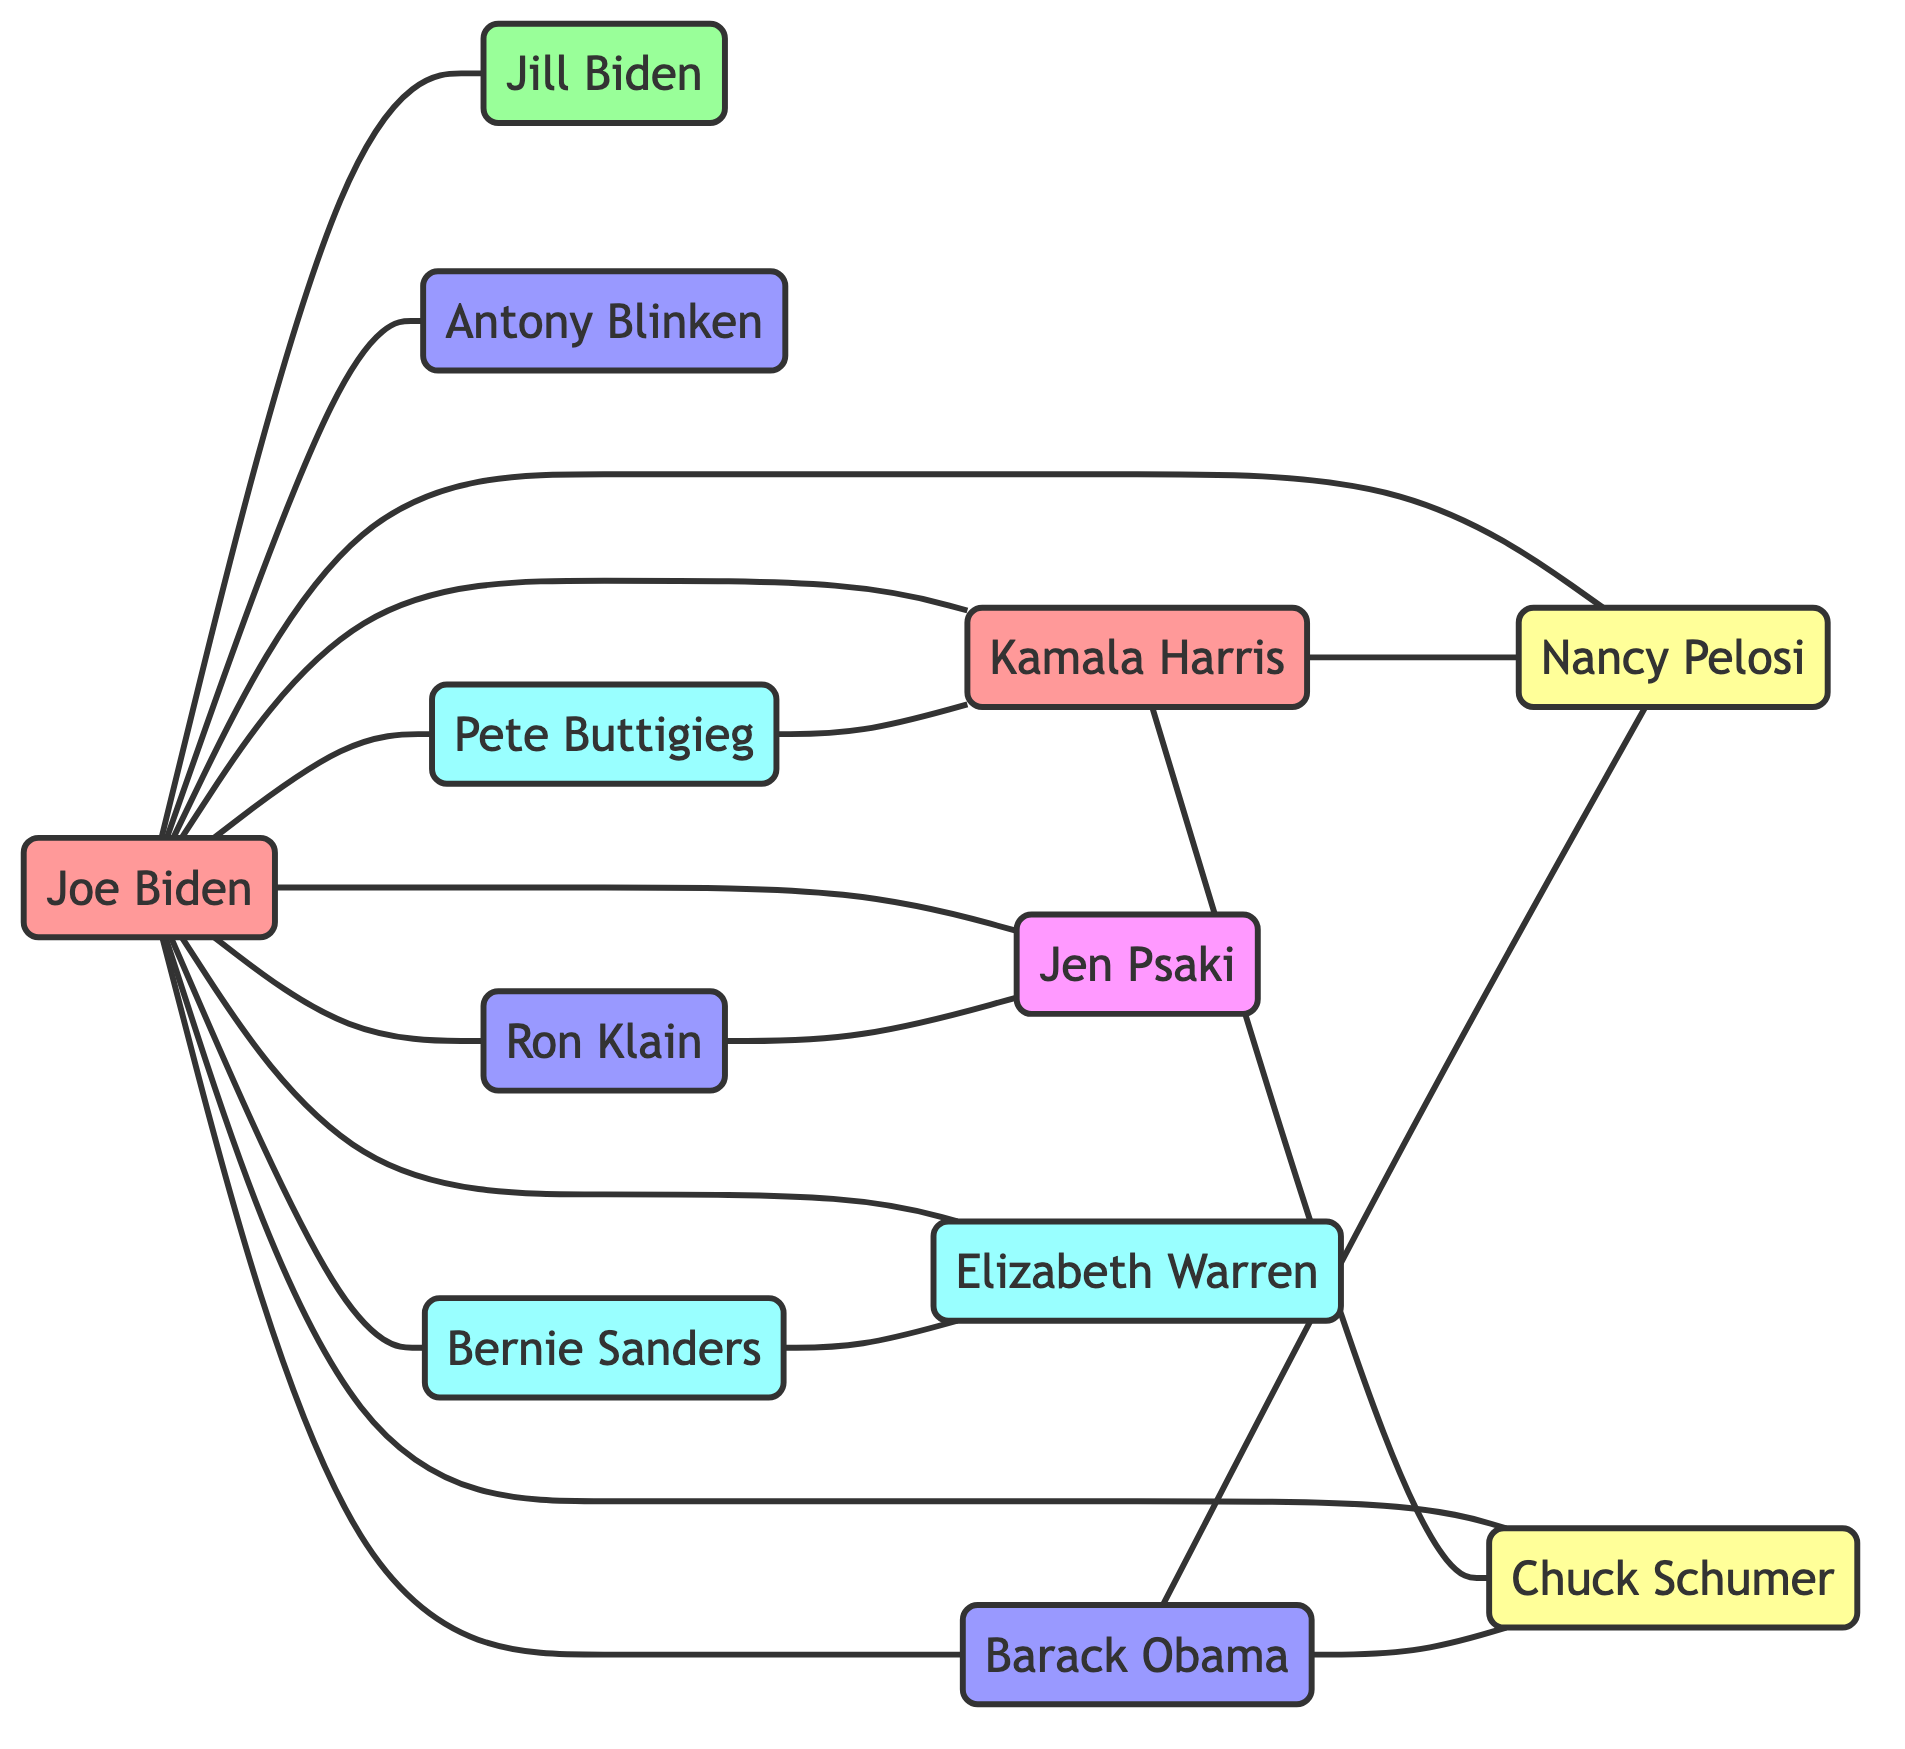What is the total number of nodes in the diagram? To find the total number of nodes, we count each unique person in the "nodes" list. There are 12 distinct nodes listed: Joe Biden, Kamala Harris, Jill Biden, Barack Obama, Nancy Pelosi, Chuck Schumer, Antony Blinken, Ron Klain, Jen Psaki, Elizabeth Warren, Bernie Sanders, and Pete Buttigieg.
Answer: 12 Who is connected to Joe Biden as an advisor? Looking at the links originating from Joe Biden, the connections include Barack Obama, Antony Blinken, and Ron Klain. Among these, the only one categorized explicitly as an advisor is Antony Blinken.
Answer: Antony Blinken How many edges are there connecting Kamala Harris to other nodes? By examining the links involving Kamala Harris, we note that she has connections to Nancy Pelosi, Chuck Schumer, and Pete Buttigieg. This results in a total of 3 edges connecting her to other nodes.
Answer: 3 Which leaders are connected to Nancy Pelosi? Nancy Pelosi has connections to Joe Biden, Kamala Harris, Chuck Schumer, and Barack Obama. The question asks for the leaders connected to her; the notable connections are Joe Biden, Kamala Harris, and Chuck Schumer.
Answer: Joe Biden, Kamala Harris, Chuck Schumer Identify a key supporter connected to Pete Buttigieg. Reviewing the links reveals that Pete Buttigieg is connected to Kamala Harris, and among other connections, the notable key supporter category he belongs to overlaps with Bernie Sanders and Elizabeth Warren. Since the question specifies identifying a key supporter, and Pete Buttigieg is directly connected, he's a valid answer. However, he is also connected to Kamala Harris.
Answer: Kamala Harris What group does Ron Klain belong to? By examining the "nodes" section, Ron Klain is categorized under "Advisors." This is a straightforward retrieval of group information from the diagram.
Answer: Advisors How many connections does Elizabeth Warren have with other nodes? Upon checking the links, Elizabeth Warren is connected to Joe Biden and Bernie Sanders. Thus, the total connections (or edges) from her are 2.
Answer: 2 Which node has the most connections to Joe Biden? The primary node with the most direct connections to Joe Biden is himself, but if we consider others, the list includes Kamala Harris, Barack Obama, Nancy Pelosi, Chuck Schumer, Antony Blinken, Ron Klain, Jen Psaki, Elizabeth Warren, Bernie Sanders, and Pete Buttigieg—showing he is connected to 10 nodes.
Answer: 10 How many advisors are there in the network? From the "nodes" list, we identify those categorized as "Advisors," which are Barack Obama, Antony Blinken, and Ron Klain. Counting these, we find there are 3 advisors.
Answer: 3 